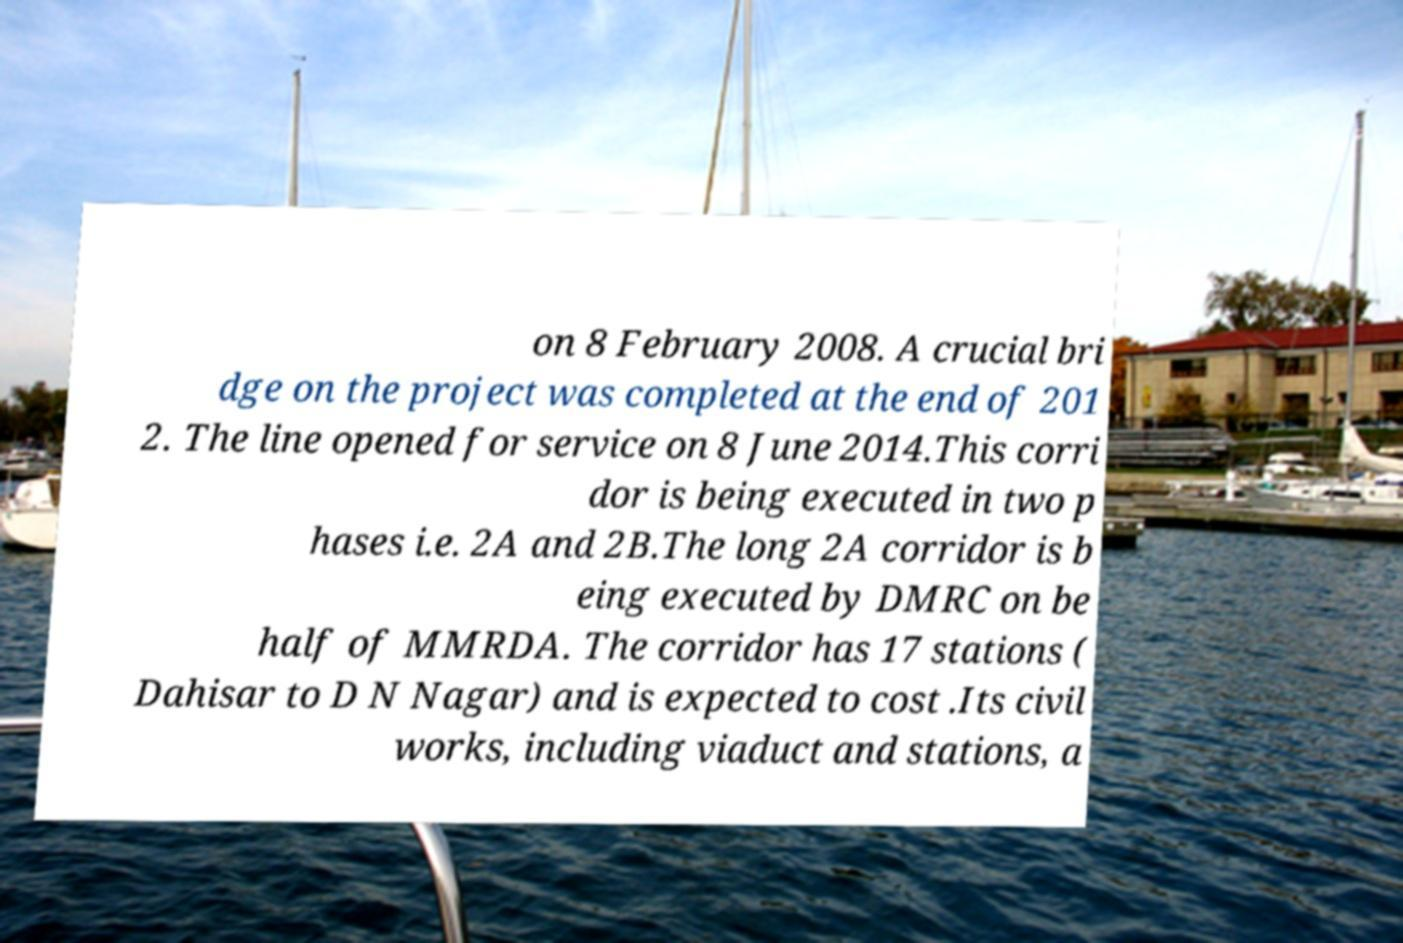There's text embedded in this image that I need extracted. Can you transcribe it verbatim? on 8 February 2008. A crucial bri dge on the project was completed at the end of 201 2. The line opened for service on 8 June 2014.This corri dor is being executed in two p hases i.e. 2A and 2B.The long 2A corridor is b eing executed by DMRC on be half of MMRDA. The corridor has 17 stations ( Dahisar to D N Nagar) and is expected to cost .Its civil works, including viaduct and stations, a 